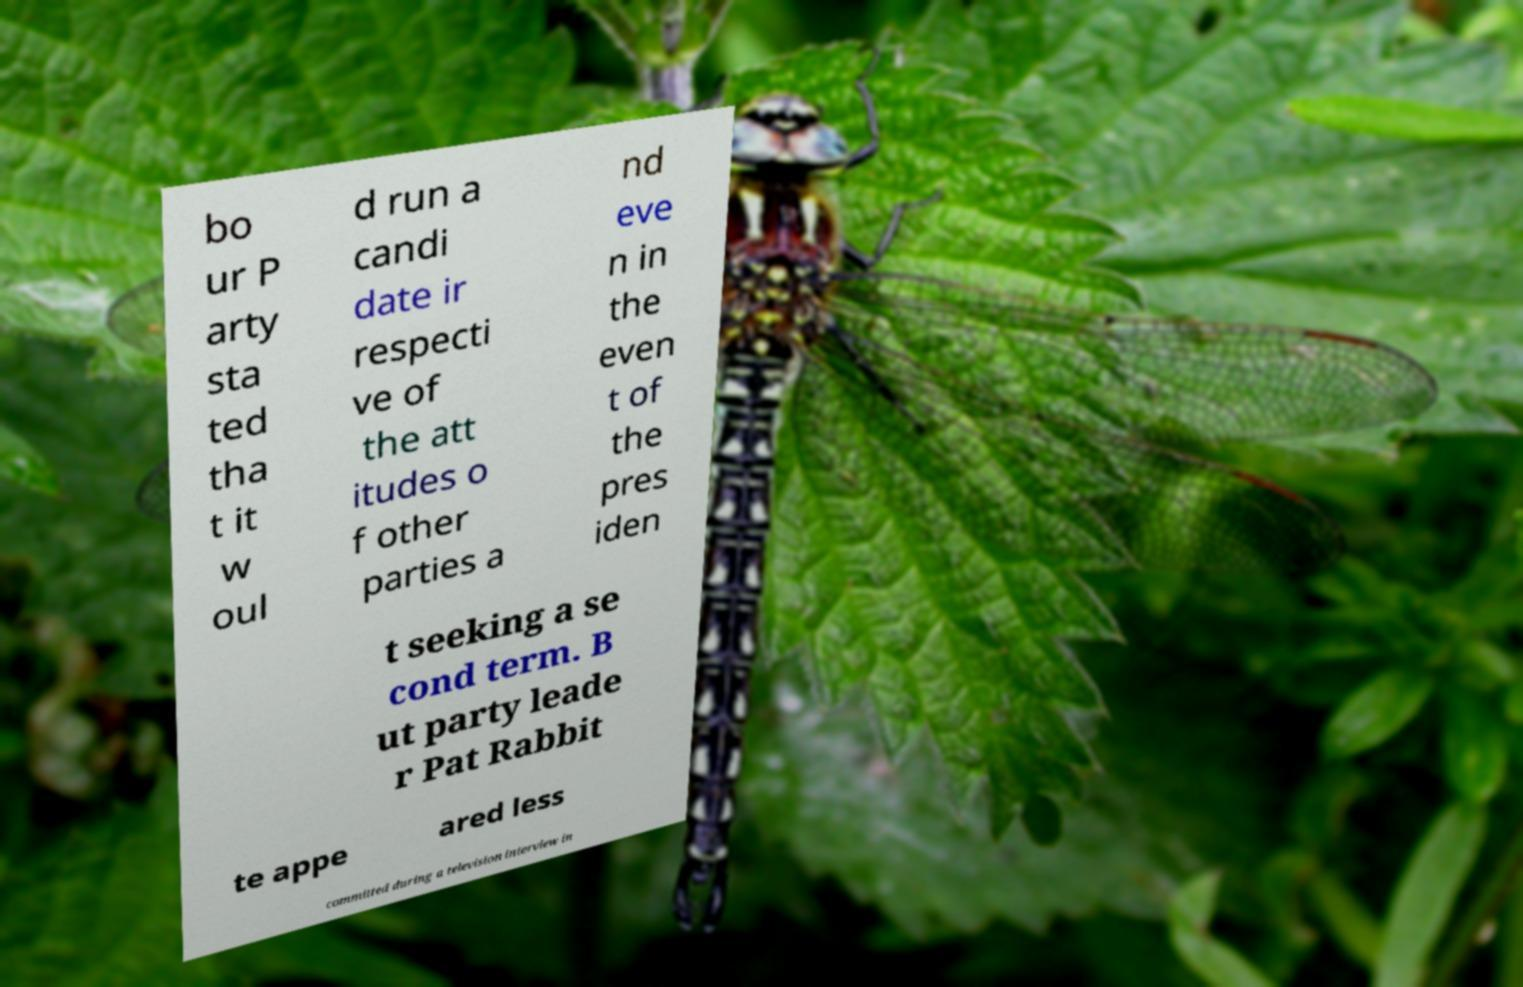Could you assist in decoding the text presented in this image and type it out clearly? bo ur P arty sta ted tha t it w oul d run a candi date ir respecti ve of the att itudes o f other parties a nd eve n in the even t of the pres iden t seeking a se cond term. B ut party leade r Pat Rabbit te appe ared less committed during a television interview in 